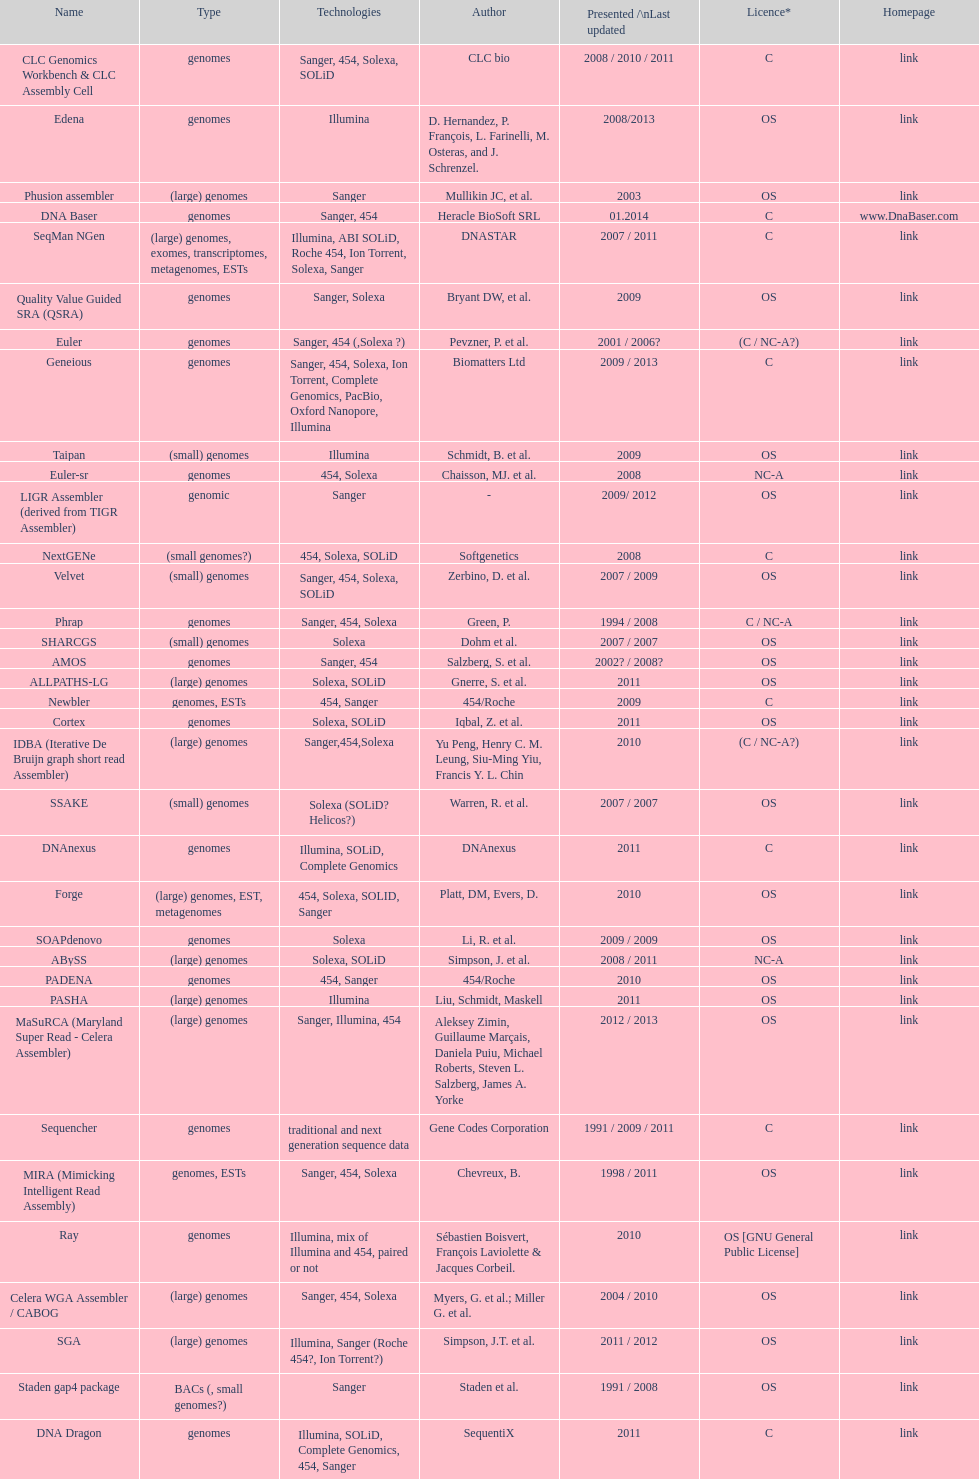What is the newest presentation or updated? DNA Baser. 